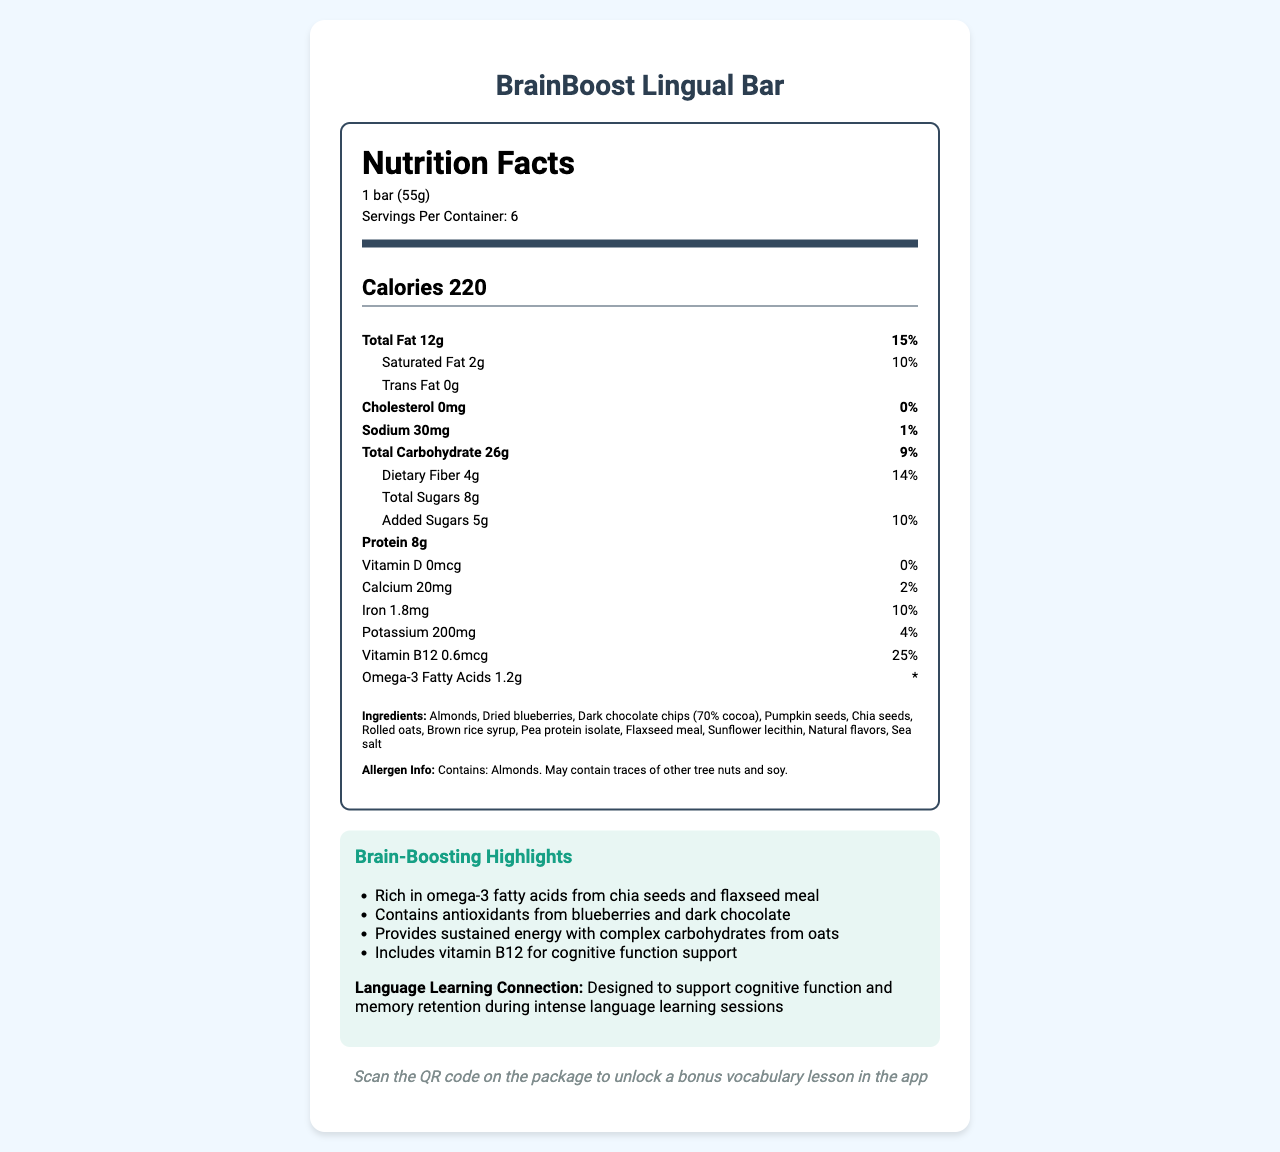what is the serving size of the BrainBoost Lingual Bar? The serving size is listed at the beginning of the Nutrition Facts Label under the product name and serving information.
Answer: 1 bar (55g) how many servings are there per container? The number of servings per container is stated just beneath the serving size on the Nutrition Facts Label.
Answer: 6 how many calories does one bar contain? The calorie content per serving is prominently displayed in a larger, bold font under the serving information.
Answer: 220 how much protein is in each serving? The protein content is listed towards the middle of the Nutrition Facts Label.
Answer: 8g what are the brain-boosting highlights of this snack? The brain-boosting highlights are mentioned in a dedicated section at the end of the label.
Answer: Rich in omega-3 fatty acids from chia seeds and flaxseed meal, Contains antioxidants from blueberries and dark chocolate, Provides sustained energy with complex carbohydrates from oats, Includes vitamin B12 for cognitive function support how much saturated fat does one bar contain? The amount of saturated fat is listed within the Total Fat section in the Nutrition Facts Label.
Answer: 2g which vitamin present in the bar supports cognitive function? A. Vitamin D B. Calcium C. Vitamin B12 D. Iron The brain-boosting highlights mention that Vitamin B12 supports cognitive function.
Answer: C. Vitamin B12 how much dietary fiber is included per serving? The amount of dietary fiber is listed in the Total Carbohydrate section of the Nutrition Facts Label.
Answer: 4g is there any trans fat in the BrainBoost Lingual Bar? The trans fat content is explicitly stated as "0g" in the Nutrition Facts Label.
Answer: No what are the main sources of omega-3 fatty acids in this bar? The brain-boosting highlights specify that chia seeds and flaxseed meal are rich in omega-3 fatty acids.
Answer: Chia seeds and flaxseed meal how should the BrainBoost Lingual Bar be integrated with the language learning app? A. Enter a code manually in the app B. Scan a QR code on the package C. Submit a photo of the bar in the app The app integration section mentions that scanning the QR code on the package will unlock a bonus vocabulary lesson in the app.
Answer: B. Scan a QR code on the package does the BrainBoost Lingual Bar contain any almonds? The Ingredients section clearly lists almonds as one of the components of the bar.
Answer: Yes is the BrainBoost Lingual Bar an excellent source of calcium? The calcium content per serving is 20mg, which is only 2% of the daily value, indicating it is not an excellent source.
Answer: No provide a summary of the entire document. This summary reflects the structured nutritional content, brain-boosting highlights, language learning connection, and app integration discussed in the document.
Answer: The document provides detailed nutritional information about the BrainBoost Lingual Bar, including its serving size, calorie content, and amounts of various nutrients such as fat, carbohydrates, protein, vitamins, and minerals. It highlights the brain-boosting ingredients like omega-3 fatty acids from chia seeds and flaxseed meal, antioxidants from blueberries and dark chocolate, and vitamin B12 for cognitive function. The bar is designed to support cognitive function during language learning sessions and includes a QR code for app integration to unlock a bonus lesson. The Ingredient list and allergen information are also provided. what's the cost of the BrainBoost Lingual Bar? The document contains detailed nutritional information, ingredients, and integration with a language learning app but does not provide any information regarding the cost of the bar.
Answer: Cannot be determined 